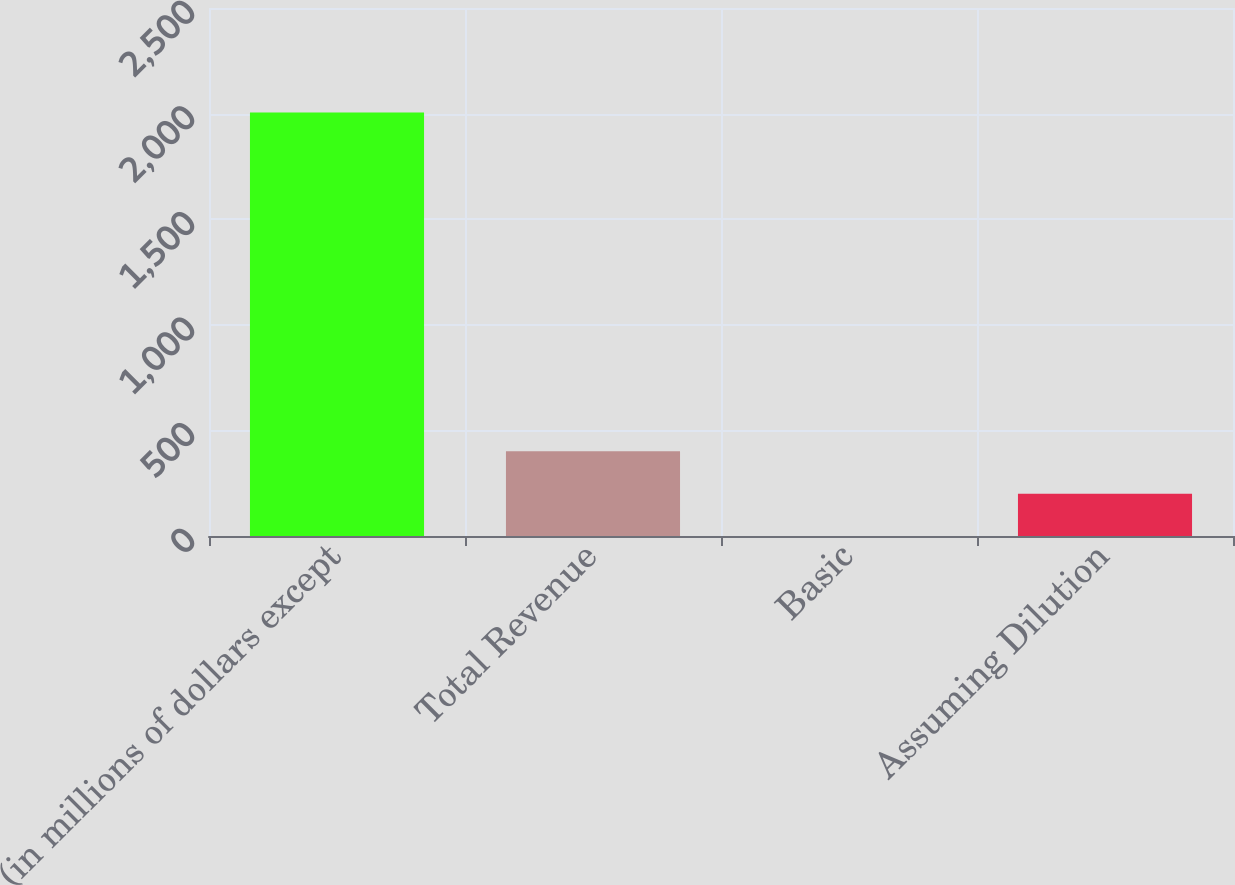<chart> <loc_0><loc_0><loc_500><loc_500><bar_chart><fcel>(in millions of dollars except<fcel>Total Revenue<fcel>Basic<fcel>Assuming Dilution<nl><fcel>2005<fcel>401.03<fcel>0.03<fcel>200.53<nl></chart> 